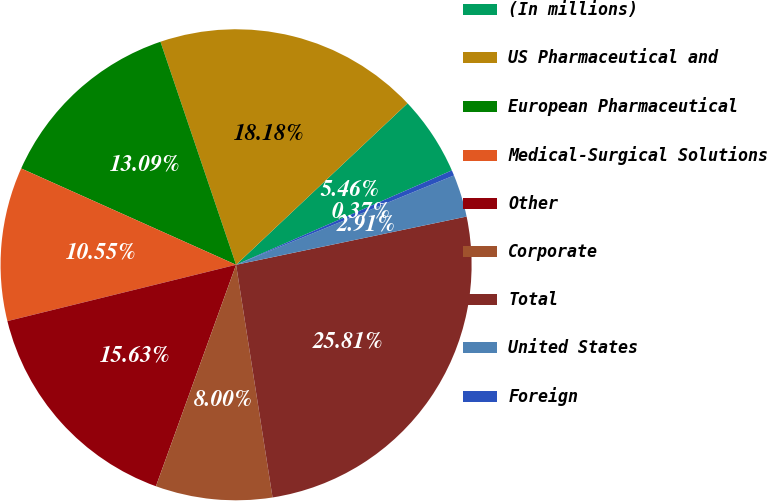Convert chart. <chart><loc_0><loc_0><loc_500><loc_500><pie_chart><fcel>(In millions)<fcel>US Pharmaceutical and<fcel>European Pharmaceutical<fcel>Medical-Surgical Solutions<fcel>Other<fcel>Corporate<fcel>Total<fcel>United States<fcel>Foreign<nl><fcel>5.46%<fcel>18.18%<fcel>13.09%<fcel>10.55%<fcel>15.63%<fcel>8.0%<fcel>25.81%<fcel>2.91%<fcel>0.37%<nl></chart> 